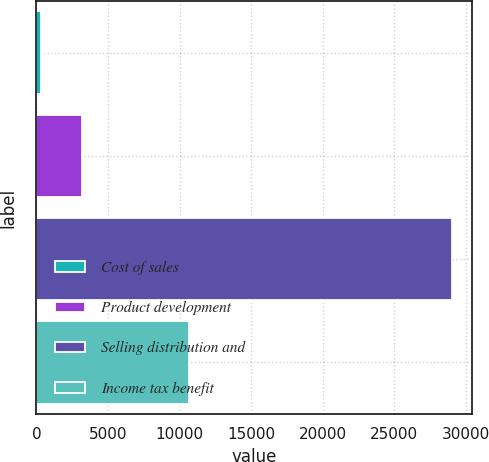<chart> <loc_0><loc_0><loc_500><loc_500><bar_chart><fcel>Cost of sales<fcel>Product development<fcel>Selling distribution and<fcel>Income tax benefit<nl><fcel>349<fcel>3216.8<fcel>29027<fcel>10658<nl></chart> 